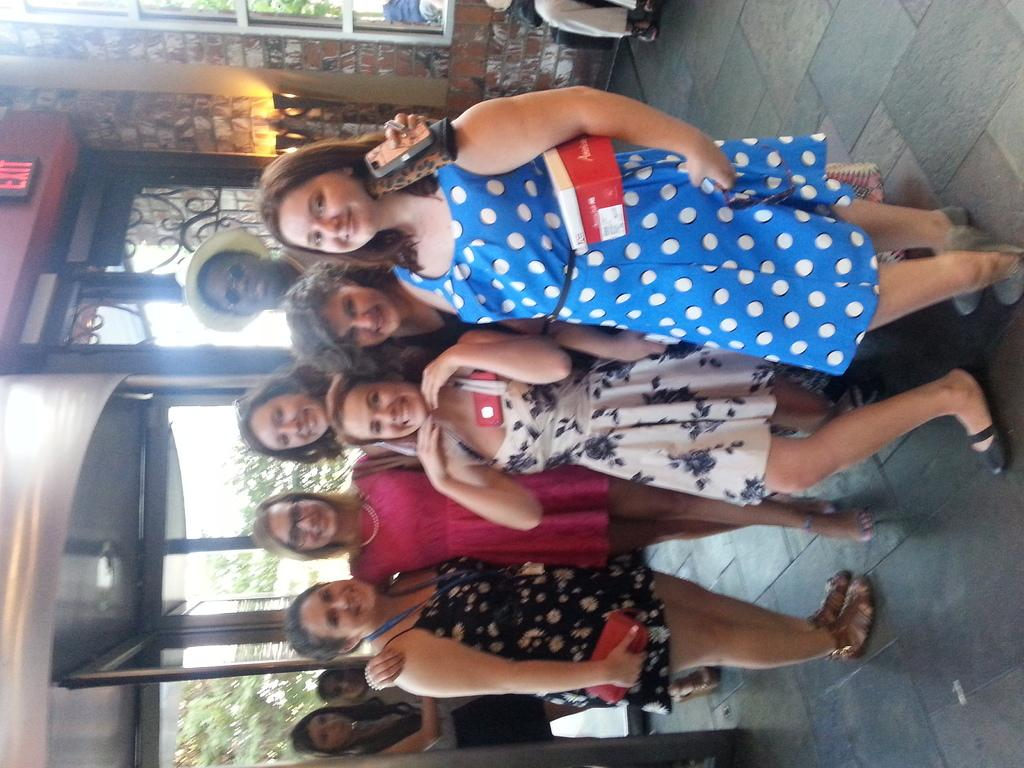How many people are in the image? There is a group of people in the image. What are the people in the image doing? The people are standing. What can be seen in the background of the image? There is a wall, a door, and trees in the background of the image. What type of glue is being used by the people in the image? There is no glue present in the image, and the people are not using any glue. 